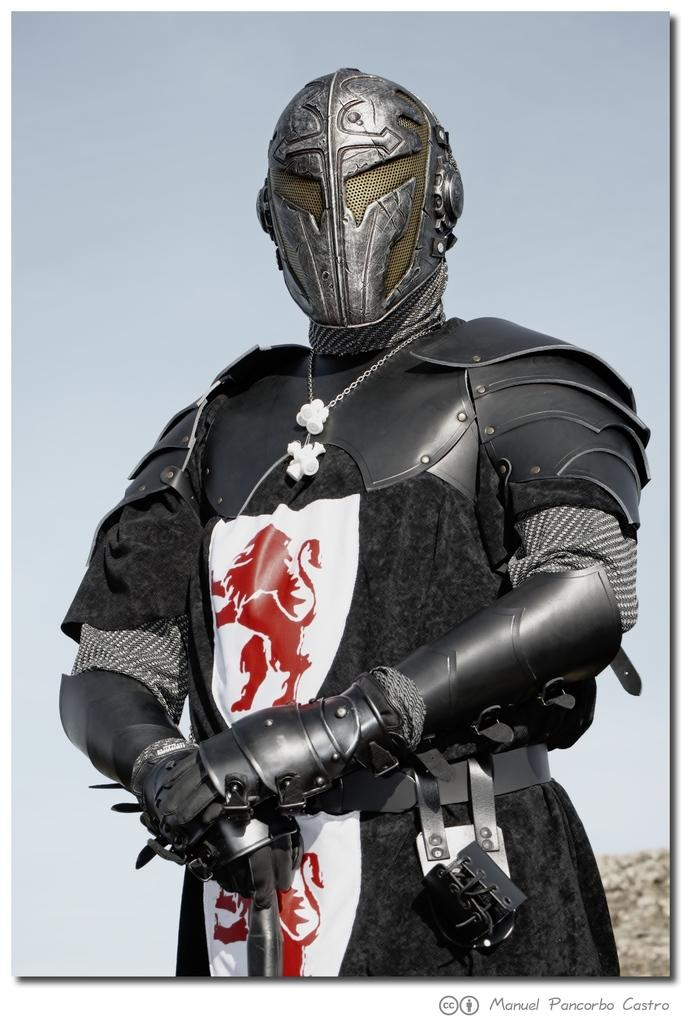What is the main subject of the image? There is a person in the image. Can you describe the person's attire? The person is wearing a black costume and a mask that covers their head. What can be seen in the background of the image? There is sky visible in the background of the image. What type of waves can be seen crashing on the shore in the image? There are no waves or shore visible in the image; it features a person wearing a black costume and mask with sky in the background. 